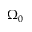<formula> <loc_0><loc_0><loc_500><loc_500>\Omega _ { 0 }</formula> 